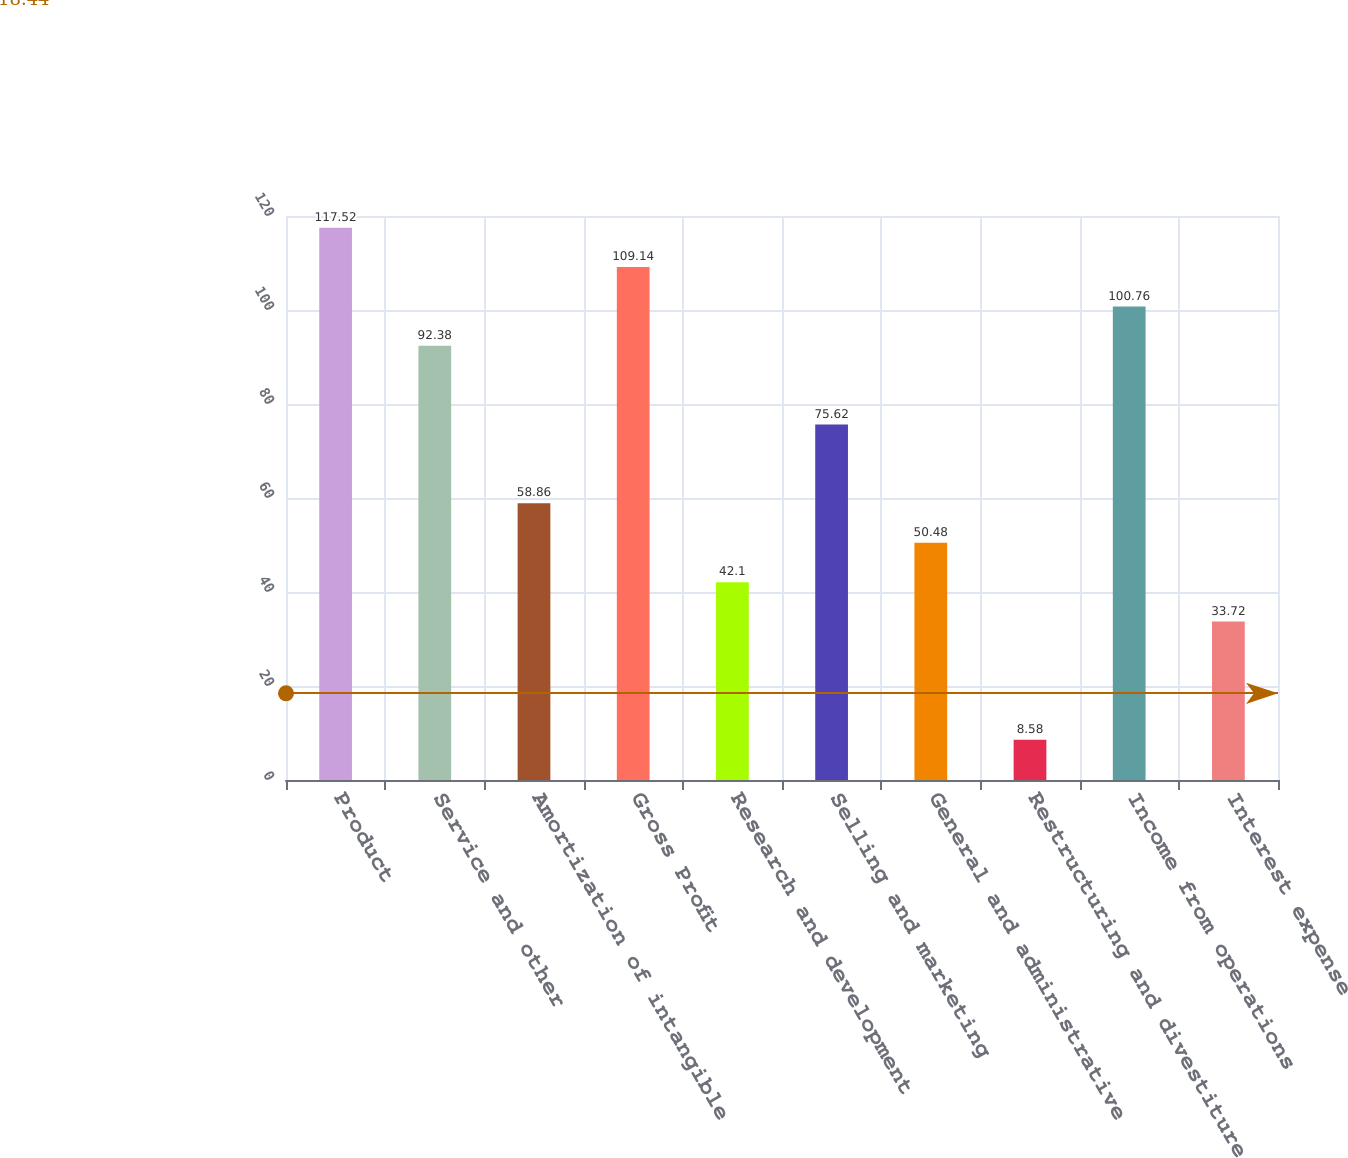Convert chart. <chart><loc_0><loc_0><loc_500><loc_500><bar_chart><fcel>Product<fcel>Service and other<fcel>Amortization of intangible<fcel>Gross Profit<fcel>Research and development<fcel>Selling and marketing<fcel>General and administrative<fcel>Restructuring and divestiture<fcel>Income from operations<fcel>Interest expense<nl><fcel>117.52<fcel>92.38<fcel>58.86<fcel>109.14<fcel>42.1<fcel>75.62<fcel>50.48<fcel>8.58<fcel>100.76<fcel>33.72<nl></chart> 